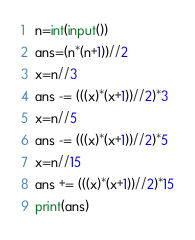Convert code to text. <code><loc_0><loc_0><loc_500><loc_500><_Python_>n=int(input())
ans=(n*(n+1))//2
x=n//3
ans -= (((x)*(x+1))//2)*3
x=n//5
ans -= (((x)*(x+1))//2)*5
x=n//15
ans += (((x)*(x+1))//2)*15
print(ans)</code> 